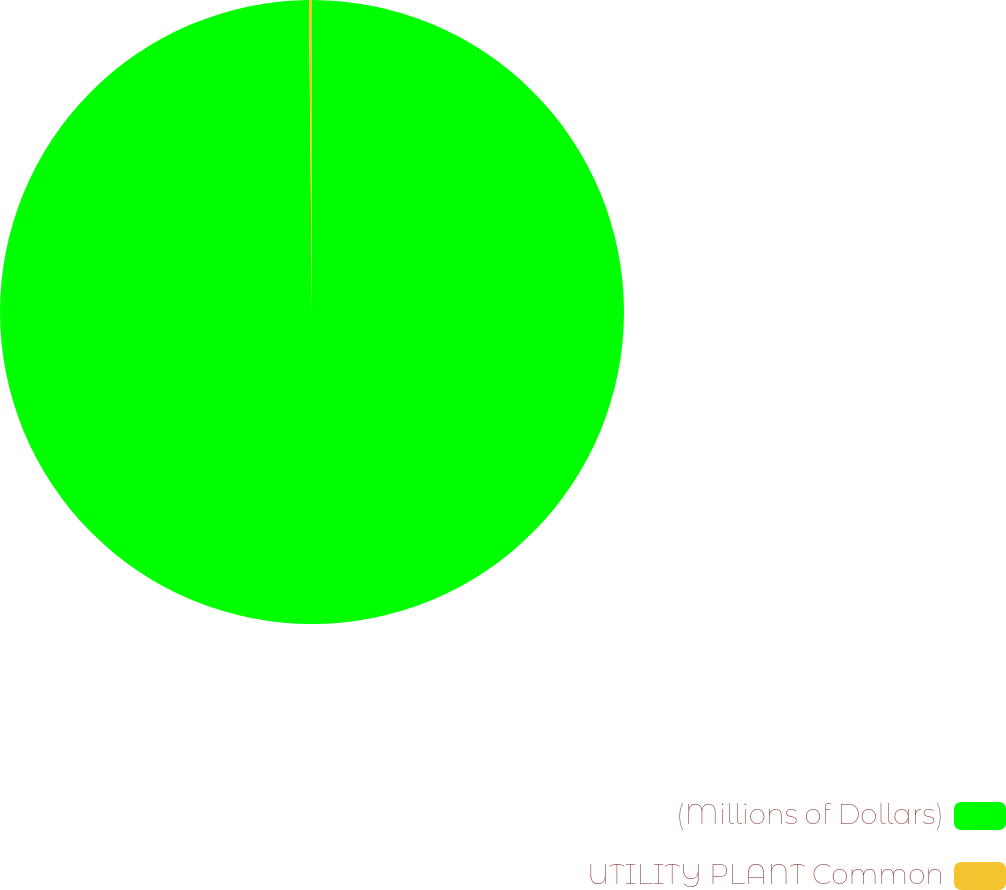Convert chart to OTSL. <chart><loc_0><loc_0><loc_500><loc_500><pie_chart><fcel>(Millions of Dollars)<fcel>UTILITY PLANT Common<nl><fcel>99.85%<fcel>0.15%<nl></chart> 